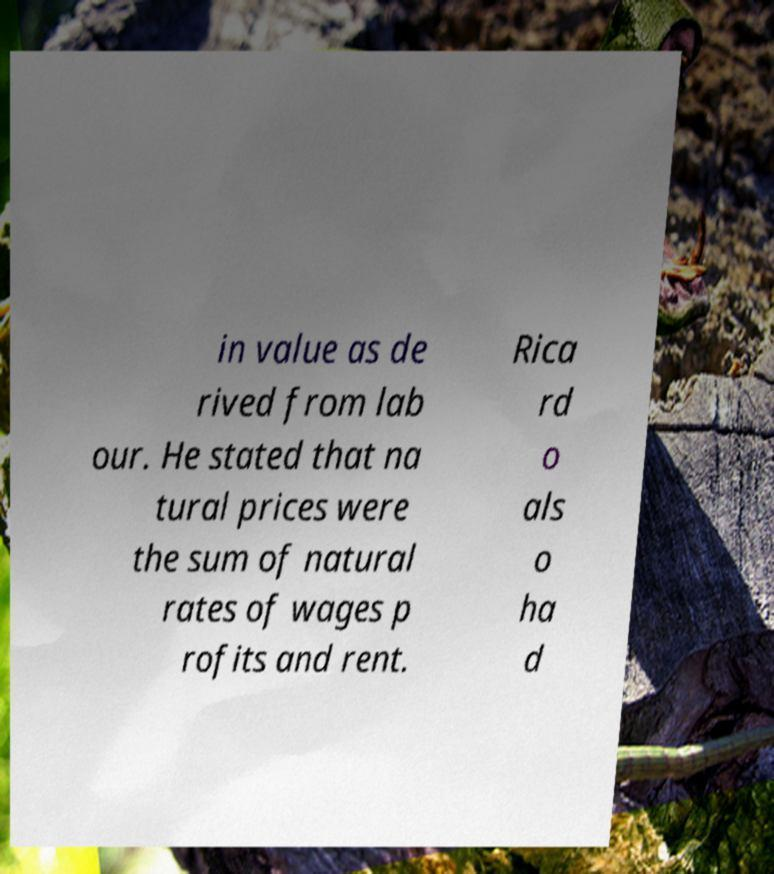For documentation purposes, I need the text within this image transcribed. Could you provide that? in value as de rived from lab our. He stated that na tural prices were the sum of natural rates of wages p rofits and rent. Rica rd o als o ha d 